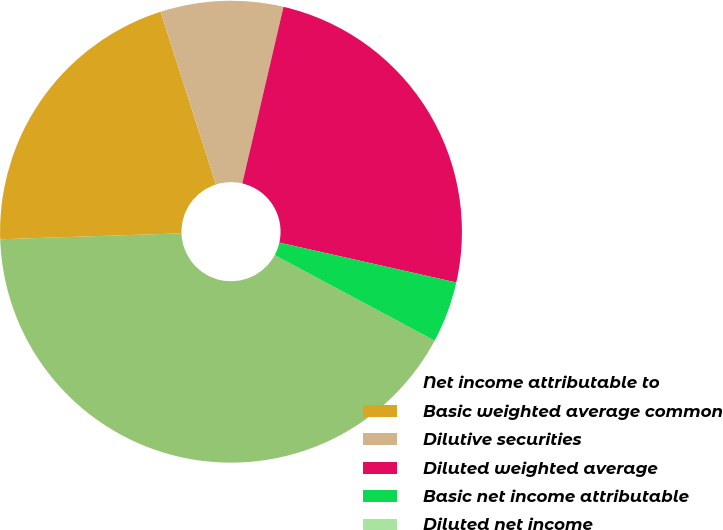Convert chart. <chart><loc_0><loc_0><loc_500><loc_500><pie_chart><fcel>Net income attributable to<fcel>Basic weighted average common<fcel>Dilutive securities<fcel>Diluted weighted average<fcel>Basic net income attributable<fcel>Diluted net income<nl><fcel>41.66%<fcel>20.59%<fcel>8.58%<fcel>24.88%<fcel>4.29%<fcel>0.0%<nl></chart> 